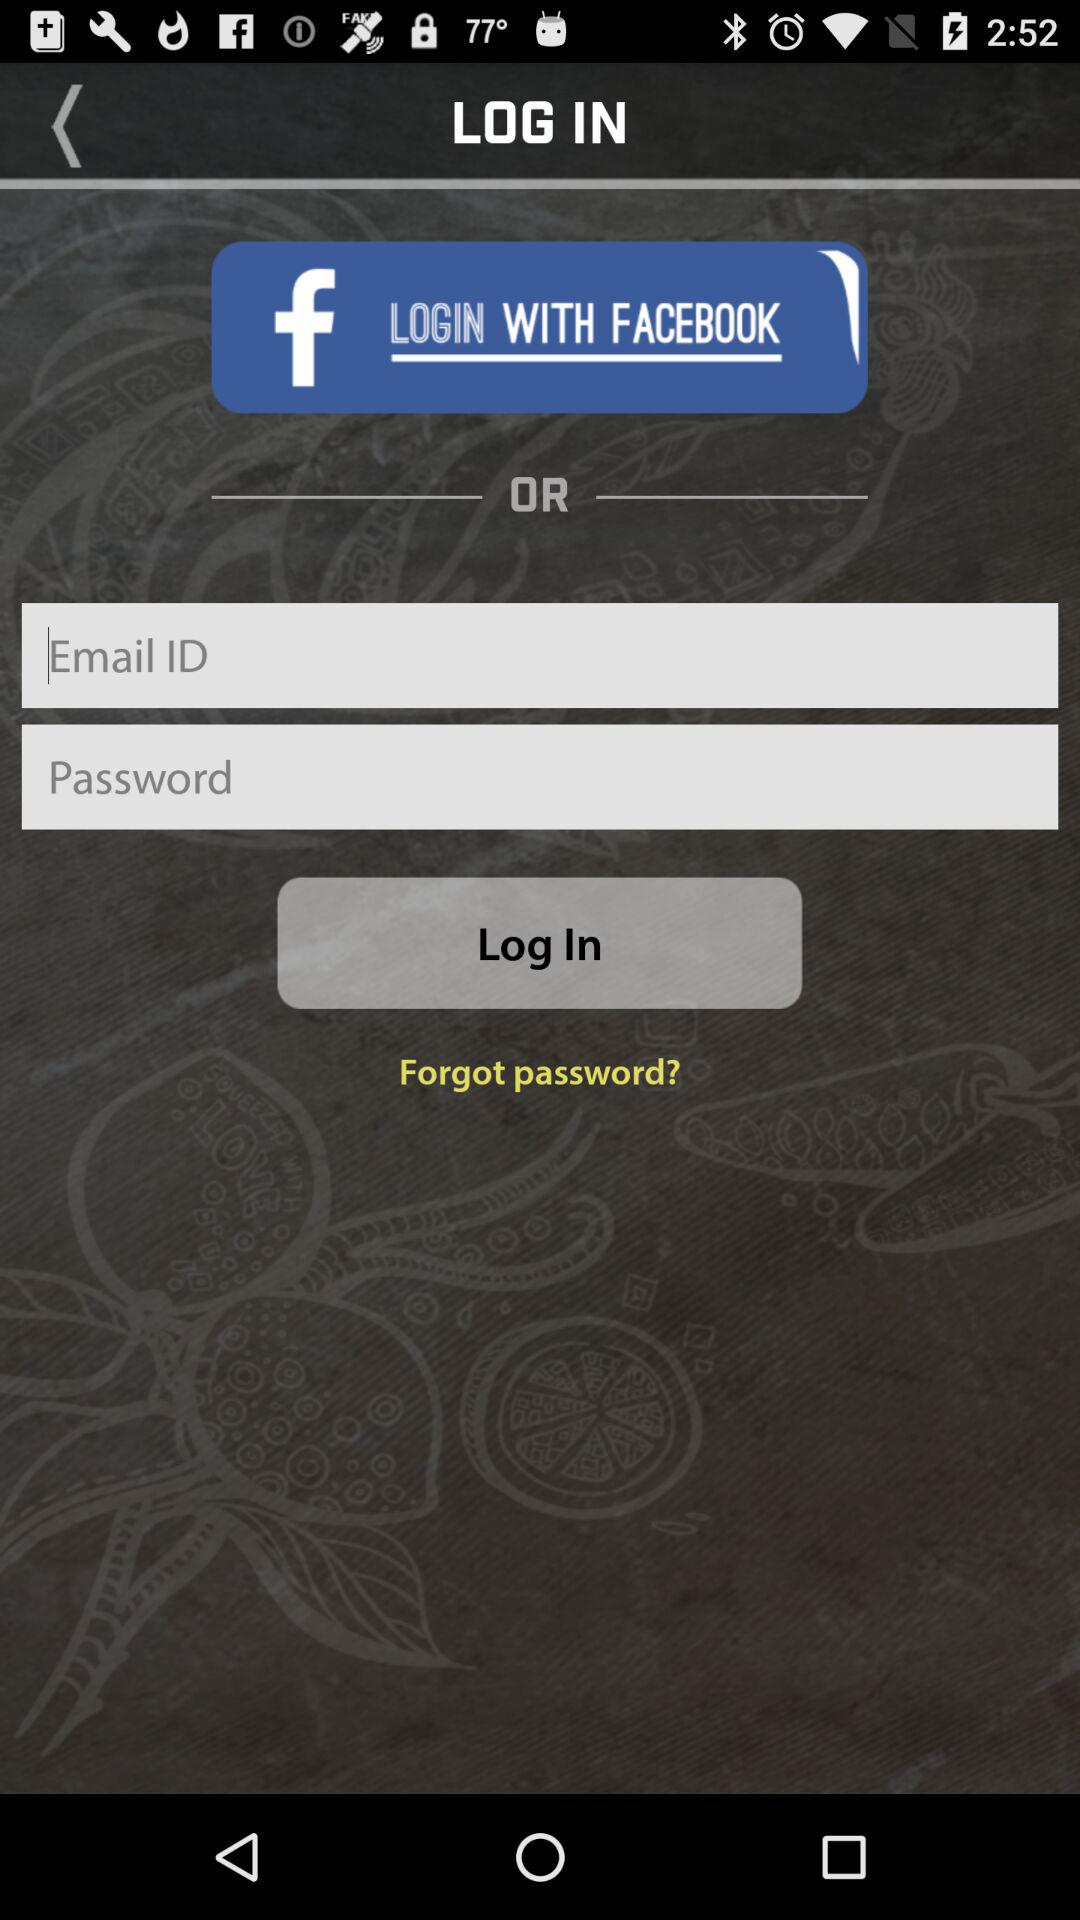How many fields are there to fill out?
Answer the question using a single word or phrase. 2 